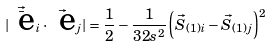<formula> <loc_0><loc_0><loc_500><loc_500>| \vec { \bar { \text { e} } } _ { i } \cdot \vec { \text { e} } _ { j } | = \frac { 1 } { 2 } - \frac { 1 } { 3 2 s ^ { 2 } } \left ( \vec { S } _ { ( 1 ) i } - \vec { S } _ { ( 1 ) j } \right ) ^ { 2 }</formula> 